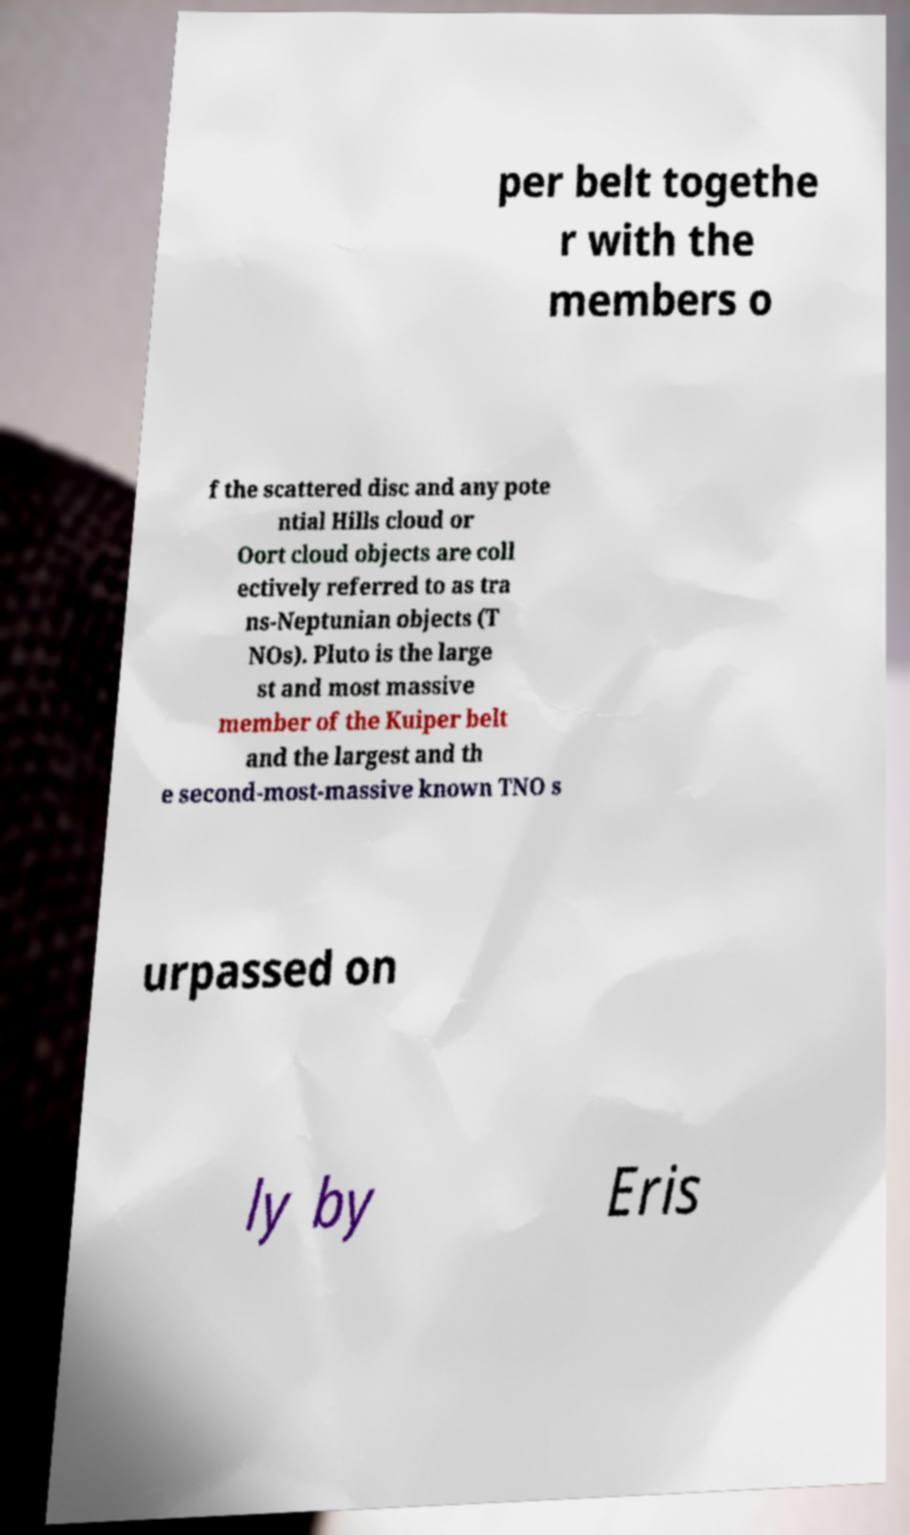Please identify and transcribe the text found in this image. per belt togethe r with the members o f the scattered disc and any pote ntial Hills cloud or Oort cloud objects are coll ectively referred to as tra ns-Neptunian objects (T NOs). Pluto is the large st and most massive member of the Kuiper belt and the largest and th e second-most-massive known TNO s urpassed on ly by Eris 